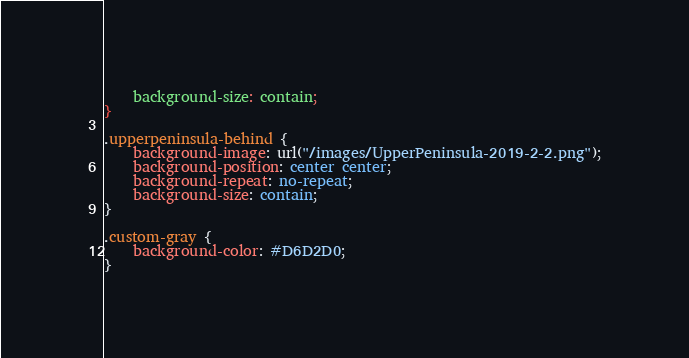<code> <loc_0><loc_0><loc_500><loc_500><_CSS_>	background-size: contain;
}

.upperpeninsula-behind {
    background-image: url("/images/UpperPeninsula-2019-2-2.png");
	background-position: center center;
	background-repeat: no-repeat;
	background-size: contain;
}

.custom-gray {
	background-color: #D6D2D0;
}</code> 